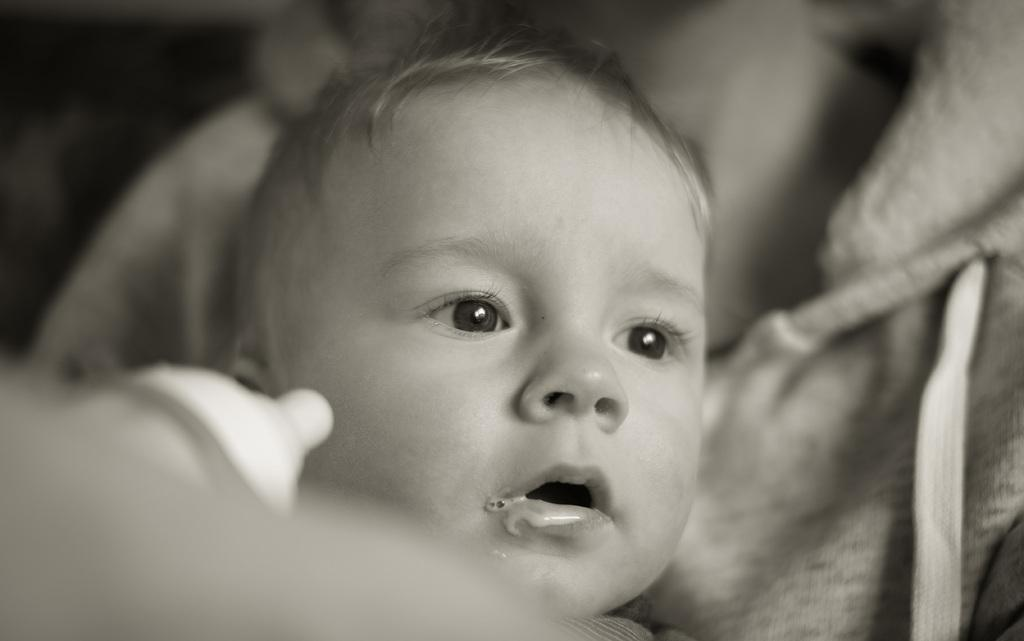What is the person in the image doing? The person is holding a baby in the image. Can you describe any objects related to the baby in the image? There is a bottle nipple visible on the left side of the image. What type of oatmeal is being prepared for the baby in the image? There is no oatmeal present in the image. What kind of beef dish is being served to the baby in the image? There is no beef dish present in the image. 